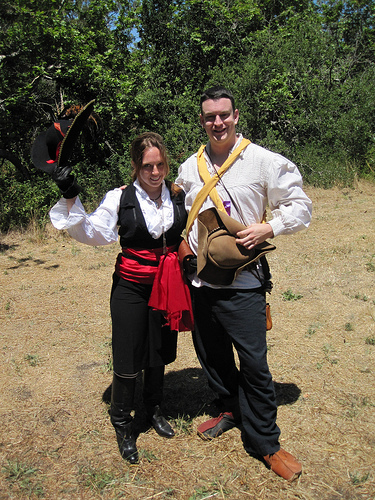<image>
Is the hat in the woman? No. The hat is not contained within the woman. These objects have a different spatial relationship. 